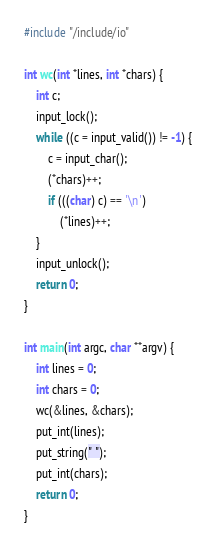Convert code to text. <code><loc_0><loc_0><loc_500><loc_500><_C++_>#include "/include/io"

int wc(int *lines, int *chars) {
    int c;
    input_lock();
    while ((c = input_valid()) != -1) {
        c = input_char();
        (*chars)++;
        if (((char) c) == '\n')
            (*lines)++;
    }
    input_unlock();
    return 0;
}

int main(int argc, char **argv) {
    int lines = 0;
    int chars = 0;
    wc(&lines, &chars);
    put_int(lines);
    put_string(" ");
    put_int(chars);
    return 0;
}</code> 